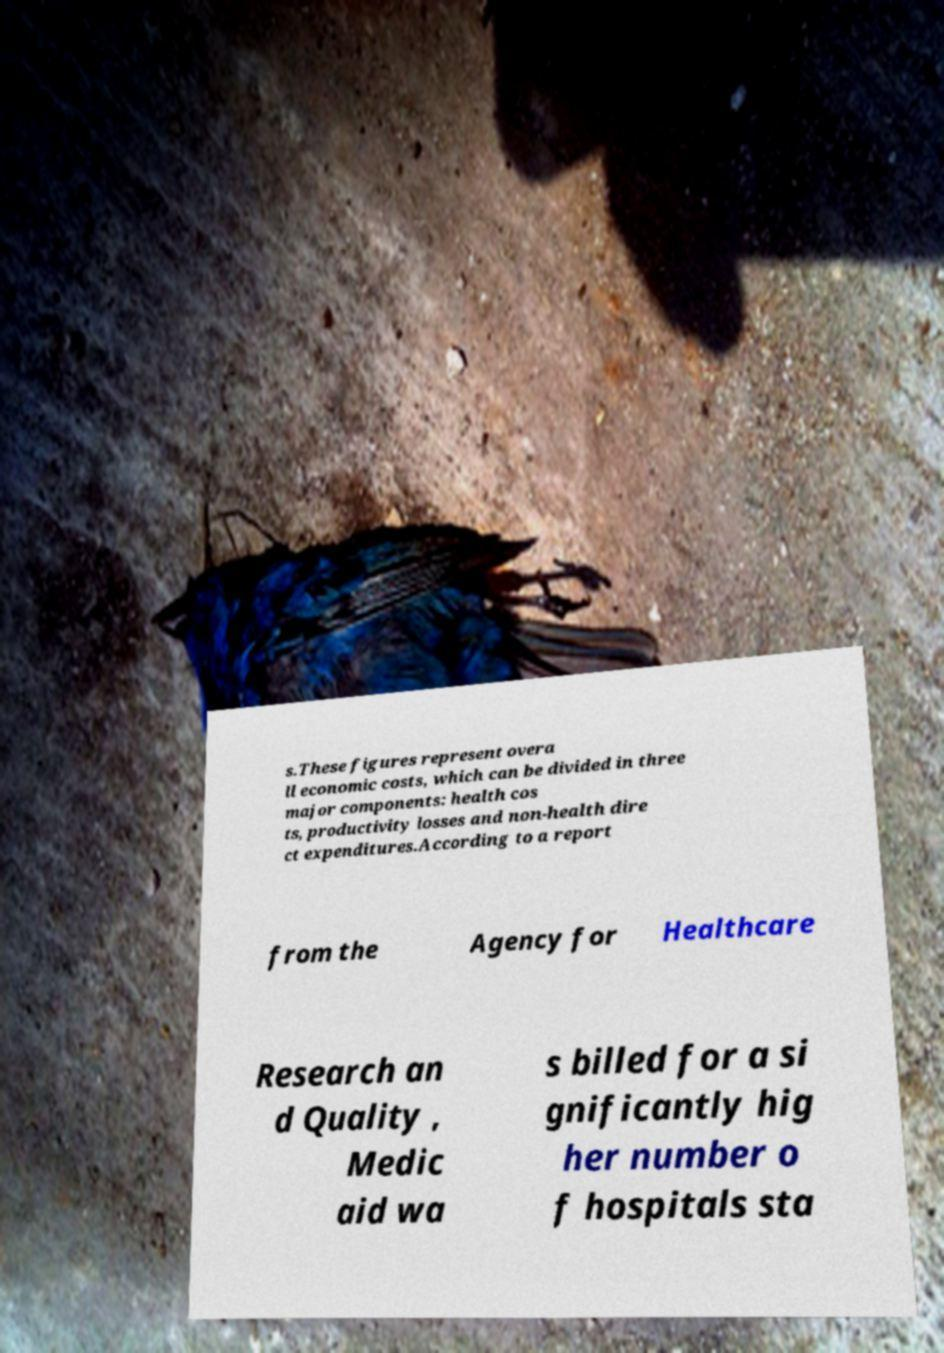Could you extract and type out the text from this image? s.These figures represent overa ll economic costs, which can be divided in three major components: health cos ts, productivity losses and non-health dire ct expenditures.According to a report from the Agency for Healthcare Research an d Quality , Medic aid wa s billed for a si gnificantly hig her number o f hospitals sta 